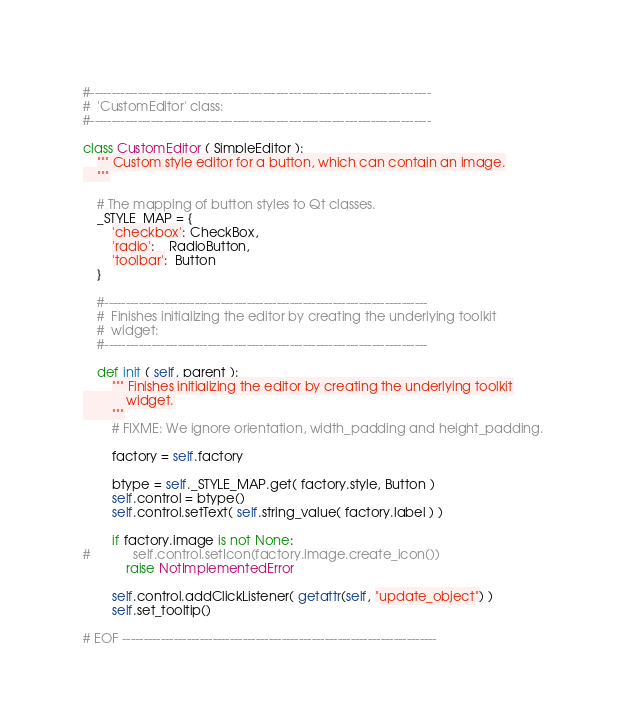Convert code to text. <code><loc_0><loc_0><loc_500><loc_500><_Python_>#-------------------------------------------------------------------------------
#  'CustomEditor' class:
#-------------------------------------------------------------------------------

class CustomEditor ( SimpleEditor ):
    """ Custom style editor for a button, which can contain an image.
    """

    # The mapping of button styles to Qt classes.
    _STYLE_MAP = {
        'checkbox': CheckBox,
        'radio':    RadioButton,
        'toolbar':  Button
    }

    #---------------------------------------------------------------------------
    #  Finishes initializing the editor by creating the underlying toolkit
    #  widget:
    #---------------------------------------------------------------------------

    def init ( self, parent ):
        """ Finishes initializing the editor by creating the underlying toolkit
            widget.
        """
        # FIXME: We ignore orientation, width_padding and height_padding.

        factory = self.factory

        btype = self._STYLE_MAP.get( factory.style, Button )
        self.control = btype()
        self.control.setText( self.string_value( factory.label ) )

        if factory.image is not None:
#            self.control.setIcon(factory.image.create_icon())
            raise NotImplementedError

        self.control.addClickListener( getattr(self, "update_object") )
        self.set_tooltip()

# EOF -------------------------------------------------------------------------
</code> 